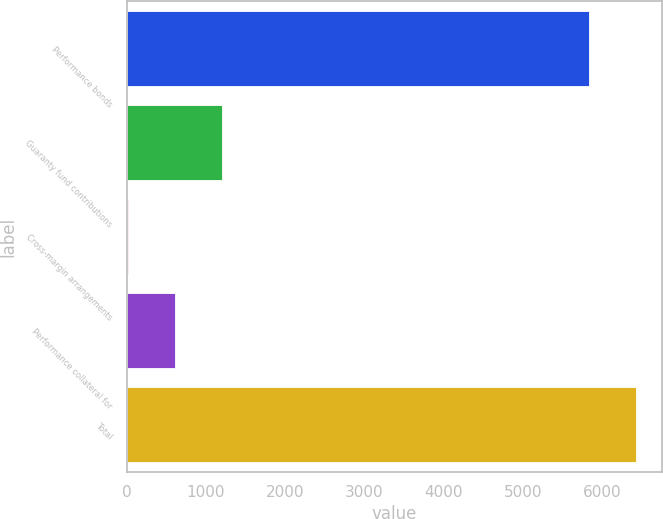<chart> <loc_0><loc_0><loc_500><loc_500><bar_chart><fcel>Performance bonds<fcel>Guaranty fund contributions<fcel>Cross-margin arrangements<fcel>Performance collateral for<fcel>Total<nl><fcel>5834.6<fcel>1204.86<fcel>10.6<fcel>607.73<fcel>6431.73<nl></chart> 